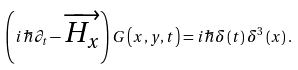<formula> <loc_0><loc_0><loc_500><loc_500>\left ( i \hbar { \partial } _ { t } - \overrightarrow { H _ { x } } \right ) G \left ( x , y , t \right ) = i \hbar { \delta } \left ( t \right ) \delta ^ { 3 } \left ( x \right ) .</formula> 